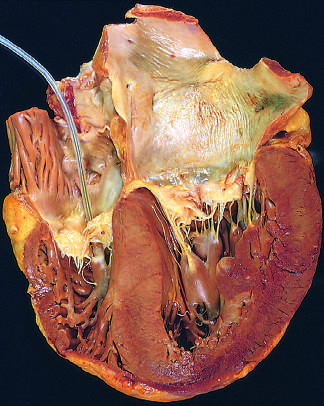s cohesive tumor in retina presented incidentally in the right ventricle?
Answer the question using a single word or phrase. No 